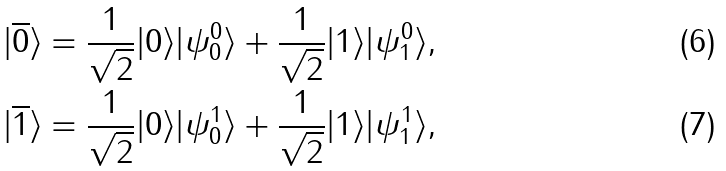<formula> <loc_0><loc_0><loc_500><loc_500>| \overline { 0 } \rangle = \frac { 1 } { \sqrt { 2 } } | 0 \rangle | \psi ^ { 0 } _ { 0 } \rangle + \frac { 1 } { \sqrt { 2 } } | 1 \rangle | \psi ^ { 0 } _ { 1 } \rangle , \\ | \overline { 1 } \rangle = \frac { 1 } { \sqrt { 2 } } | 0 \rangle | \psi ^ { 1 } _ { 0 } \rangle + \frac { 1 } { \sqrt { 2 } } | 1 \rangle | \psi ^ { 1 } _ { 1 } \rangle ,</formula> 